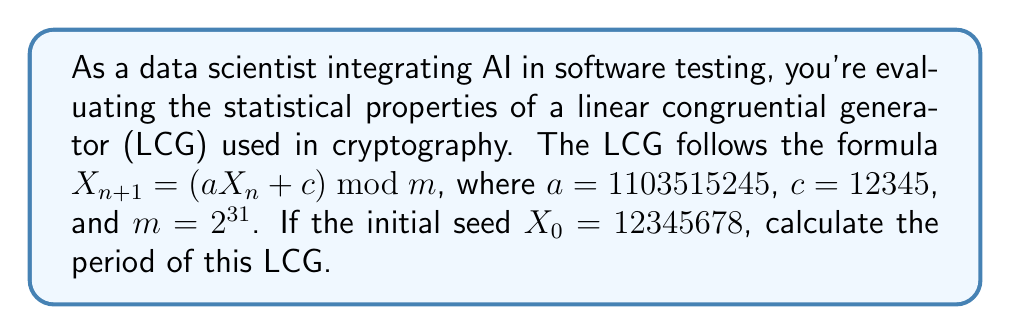Teach me how to tackle this problem. To determine the period of a linear congruential generator (LCG), we need to follow these steps:

1) For an LCG to have full period (i.e., the maximum possible period), it must satisfy three conditions:
   a) $c$ and $m$ are coprime
   b) $a-1$ is divisible by all prime factors of $m$
   c) $a-1$ is divisible by 4 if $m$ is divisible by 4

2) In this case, $m = 2^{31}$, so let's check each condition:

   a) $\gcd(c, m) = \gcd(12345, 2^{31}) = 1$ (coprime)
   
   b) The only prime factor of $2^{31}$ is 2. 
      $a - 1 = 1103515245 - 1 = 1103515244$
      $1103515244 = 2 \times 551757622$ (divisible by 2)
   
   c) $m = 2^{31}$ is divisible by 4
      $1103515244 = 4 \times 275878811$ (divisible by 4)

3) All conditions are satisfied, so this LCG has full period.

4) The period of an LCG with full period is equal to its modulus $m$.

Therefore, the period of this LCG is $2^{31}$.
Answer: $2^{31}$ 